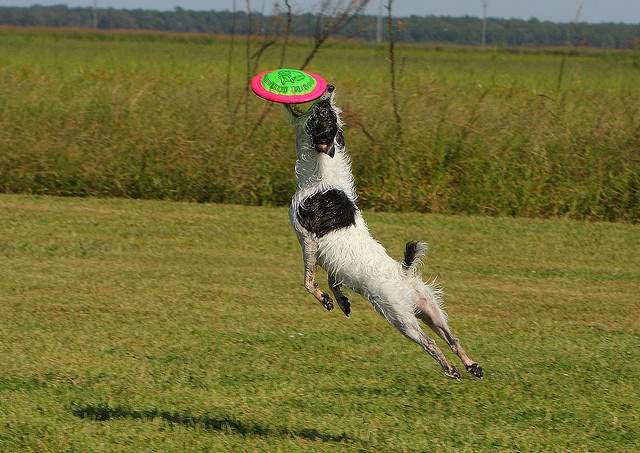Describe the objects in this image and their specific colors. I can see dog in darkgray, black, beige, and gray tones and frisbee in darkgray, lime, violet, and salmon tones in this image. 